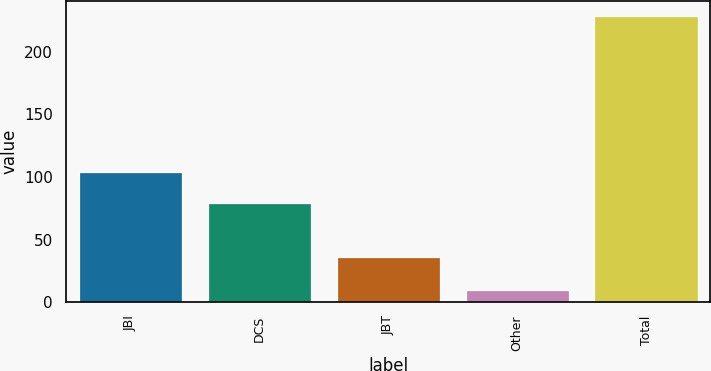Convert chart. <chart><loc_0><loc_0><loc_500><loc_500><bar_chart><fcel>JBI<fcel>DCS<fcel>JBT<fcel>Other<fcel>Total<nl><fcel>104<fcel>79<fcel>36<fcel>10<fcel>229<nl></chart> 